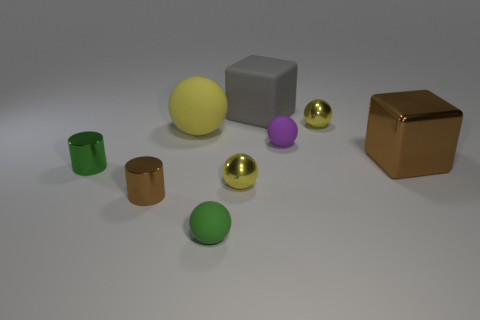The other cube that is the same size as the shiny cube is what color?
Your response must be concise. Gray. What is the size of the green metal object?
Make the answer very short. Small. Is the small yellow thing in front of the metal cube made of the same material as the big ball?
Your answer should be very brief. No. Do the gray object and the small purple rubber object have the same shape?
Keep it short and to the point. No. What is the shape of the brown metal thing to the right of the tiny shiny sphere that is behind the green object behind the tiny green matte sphere?
Keep it short and to the point. Cube. There is a green thing that is in front of the small brown cylinder; does it have the same shape as the yellow object that is left of the small green sphere?
Your response must be concise. Yes. Are there any large blue cylinders made of the same material as the purple ball?
Give a very brief answer. No. What color is the metal thing behind the large brown metal thing behind the small green object on the left side of the tiny brown thing?
Offer a terse response. Yellow. Are the tiny yellow sphere that is behind the green metallic thing and the big thing to the left of the large matte cube made of the same material?
Your answer should be very brief. No. There is a green object that is on the right side of the big matte sphere; what shape is it?
Offer a terse response. Sphere. 